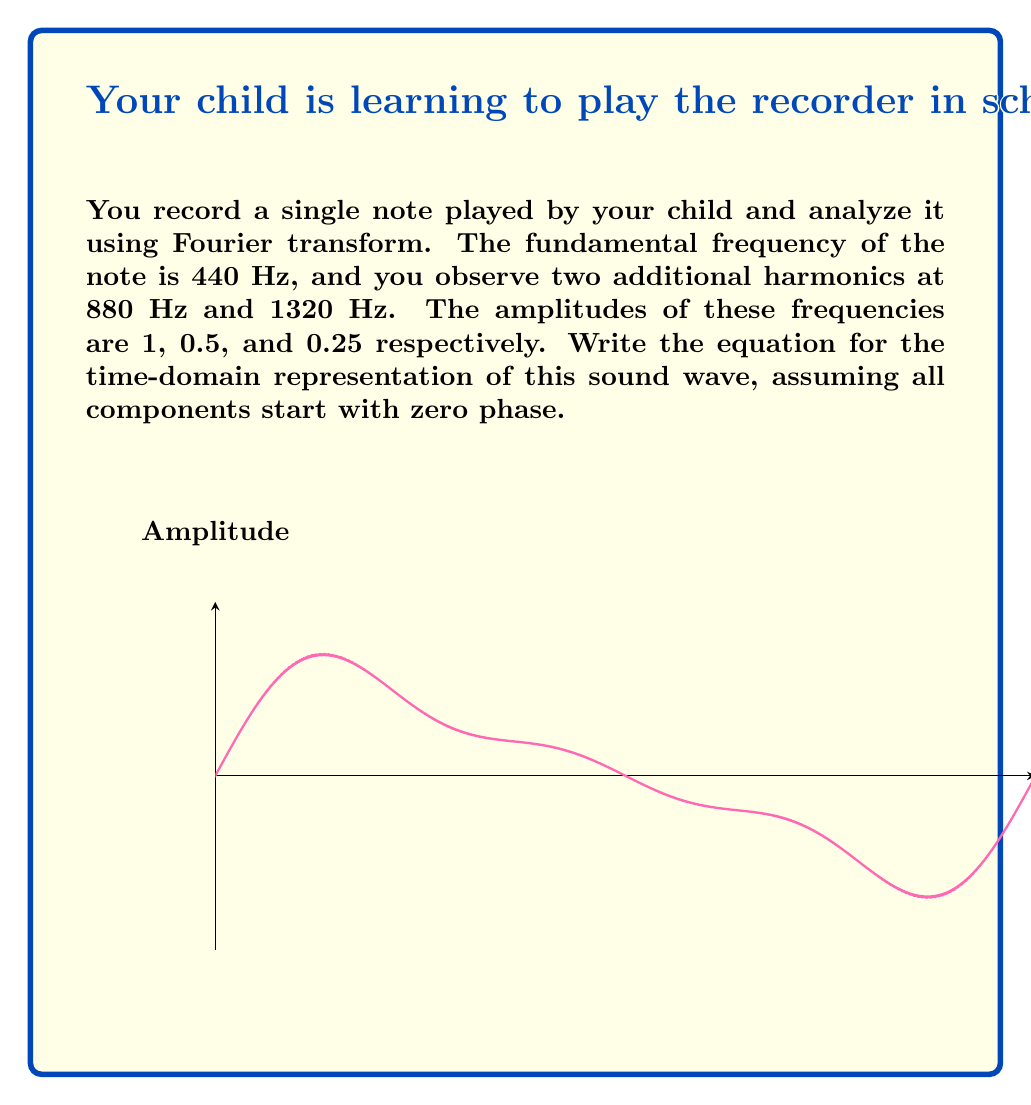What is the answer to this math problem? Let's approach this step-by-step:

1) The Fourier transform tells us that any complex waveform can be represented as a sum of sine waves with different frequencies, amplitudes, and phases.

2) In this case, we have three components:
   - Fundamental frequency: 440 Hz with amplitude 1
   - First harmonic: 880 Hz with amplitude 0.5
   - Second harmonic: 1320 Hz with amplitude 0.25

3) The general form of a sine wave is:
   $A \sin(2\pi ft + \phi)$
   where $A$ is the amplitude, $f$ is the frequency, $t$ is time, and $\phi$ is the phase.

4) Since all components start with zero phase, we can omit the phase term.

5) Let's write each component:
   - Fundamental: $1 \sin(2\pi \cdot 440t)$
   - First harmonic: $0.5 \sin(2\pi \cdot 880t)$
   - Second harmonic: $0.25 \sin(2\pi \cdot 1320t)$

6) The total waveform is the sum of these components:

   $y(t) = 1 \sin(2\pi \cdot 440t) + 0.5 \sin(2\pi \cdot 880t) + 0.25 \sin(2\pi \cdot 1320t)$

7) Simplify by factoring out $2\pi$:

   $y(t) = \sin(880\pi t) + 0.5 \sin(1760\pi t) + 0.25 \sin(2640\pi t)$

This is the time-domain representation of the sound wave.
Answer: $y(t) = \sin(880\pi t) + 0.5 \sin(1760\pi t) + 0.25 \sin(2640\pi t)$ 